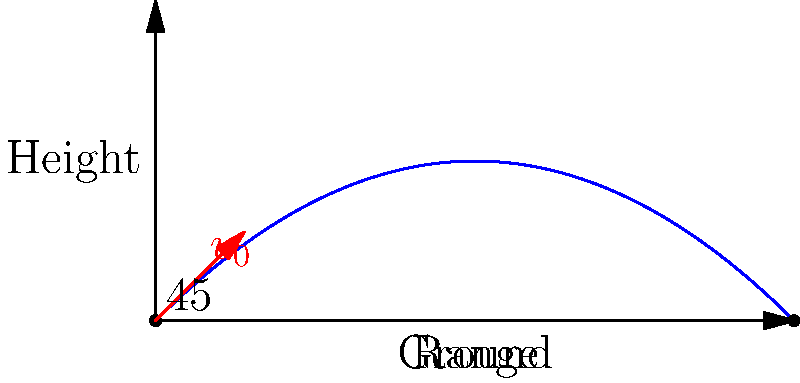An Assyrian siege engineer is designing a catapult to launch projectiles at an enemy fortress. The catapult launches a stone with an initial velocity of 50 m/s at a 45-degree angle. Assuming no air resistance, what is the maximum range of the projectile? To solve this problem, we'll use the equation for the range of a projectile launched at an angle:

1) The range equation is: $R = \frac{v_0^2 \sin(2\theta)}{g}$

2) We're given:
   - Initial velocity $v_0 = 50$ m/s
   - Launch angle $\theta = 45°$
   - Acceleration due to gravity $g = 9.8$ m/s²

3) First, let's calculate $\sin(2\theta)$:
   $\sin(2 \cdot 45°) = \sin(90°) = 1$

4) Now, let's substitute these values into our range equation:
   $R = \frac{(50 \text{ m/s})^2 \cdot 1}{9.8 \text{ m/s}^2}$

5) Simplify:
   $R = \frac{2500 \text{ m}^2/\text{s}^2}{9.8 \text{ m/s}^2}$

6) Calculate the final result:
   $R \approx 255.1$ m

Therefore, the maximum range of the projectile is approximately 255.1 meters.
Answer: 255.1 meters 